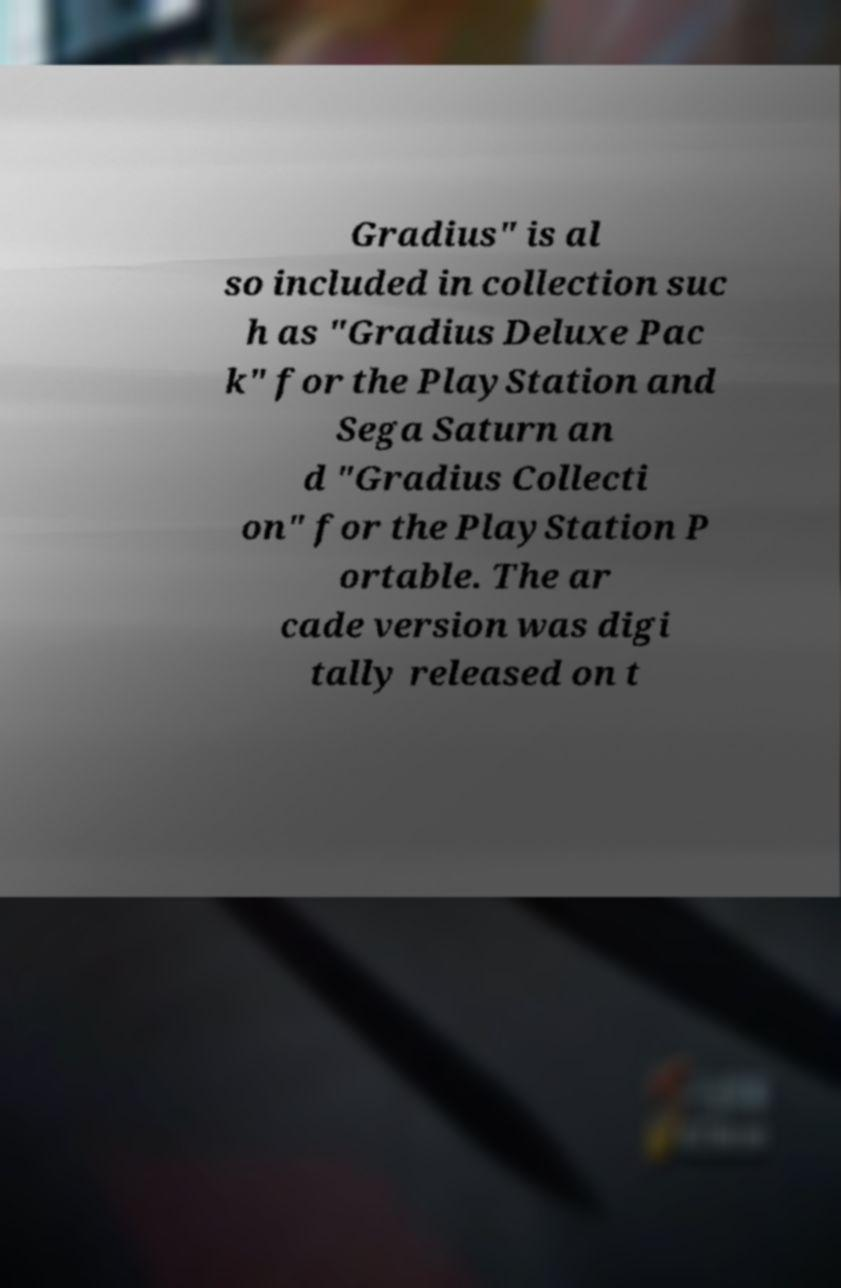I need the written content from this picture converted into text. Can you do that? Gradius" is al so included in collection suc h as "Gradius Deluxe Pac k" for the PlayStation and Sega Saturn an d "Gradius Collecti on" for the PlayStation P ortable. The ar cade version was digi tally released on t 